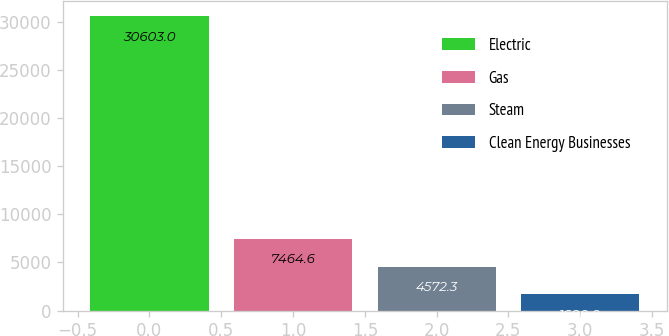Convert chart. <chart><loc_0><loc_0><loc_500><loc_500><bar_chart><fcel>Electric<fcel>Gas<fcel>Steam<fcel>Clean Energy Businesses<nl><fcel>30603<fcel>7464.6<fcel>4572.3<fcel>1680<nl></chart> 